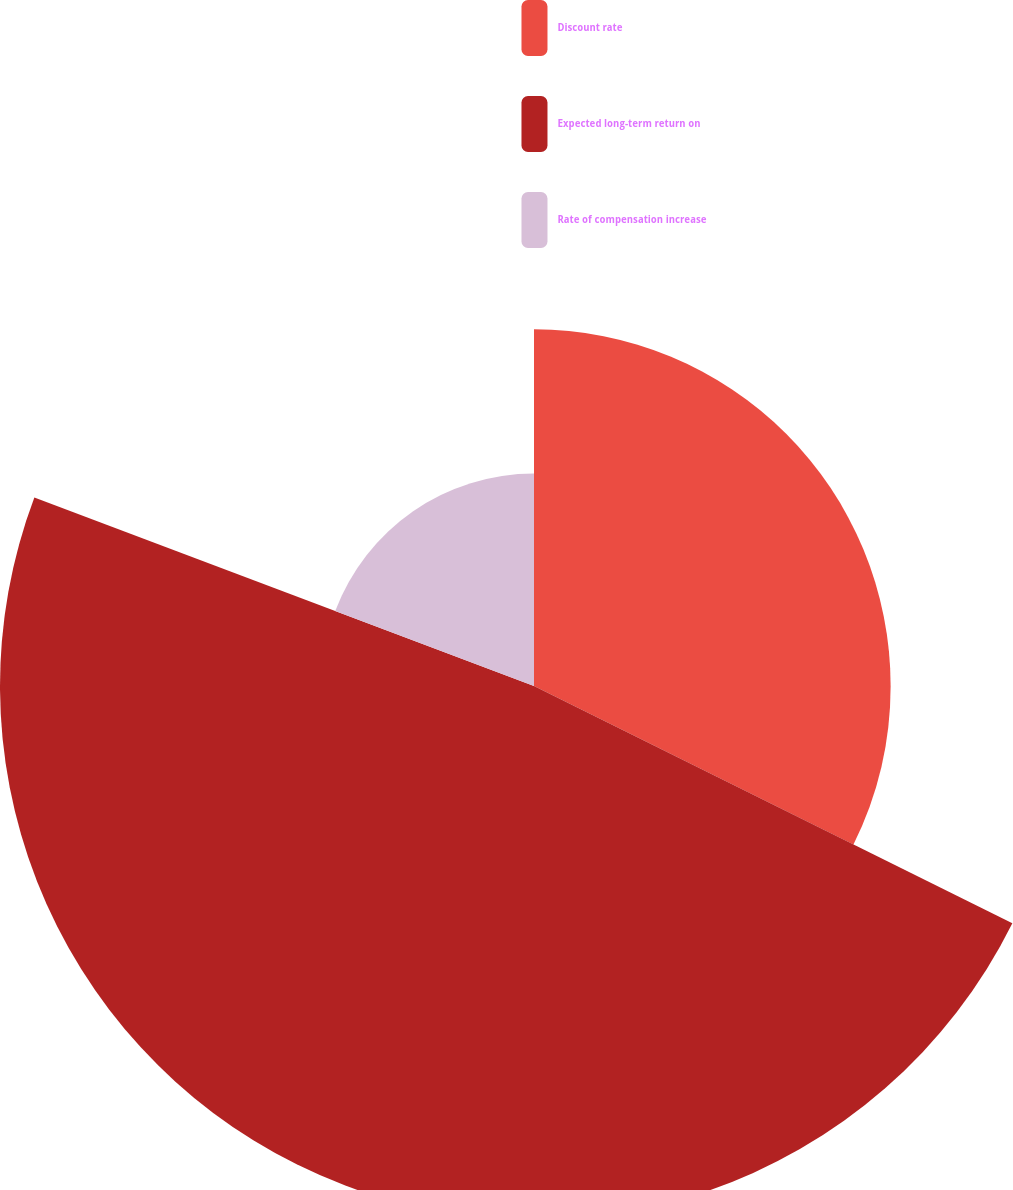<chart> <loc_0><loc_0><loc_500><loc_500><pie_chart><fcel>Discount rate<fcel>Expected long-term return on<fcel>Rate of compensation increase<nl><fcel>32.33%<fcel>48.41%<fcel>19.26%<nl></chart> 